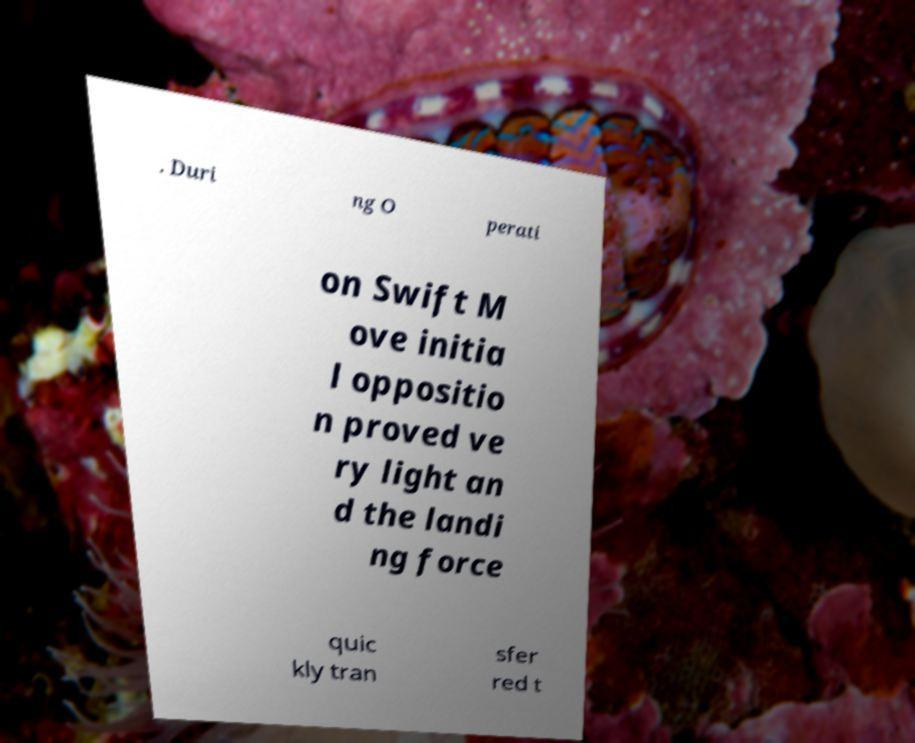Could you assist in decoding the text presented in this image and type it out clearly? . Duri ng O perati on Swift M ove initia l oppositio n proved ve ry light an d the landi ng force quic kly tran sfer red t 